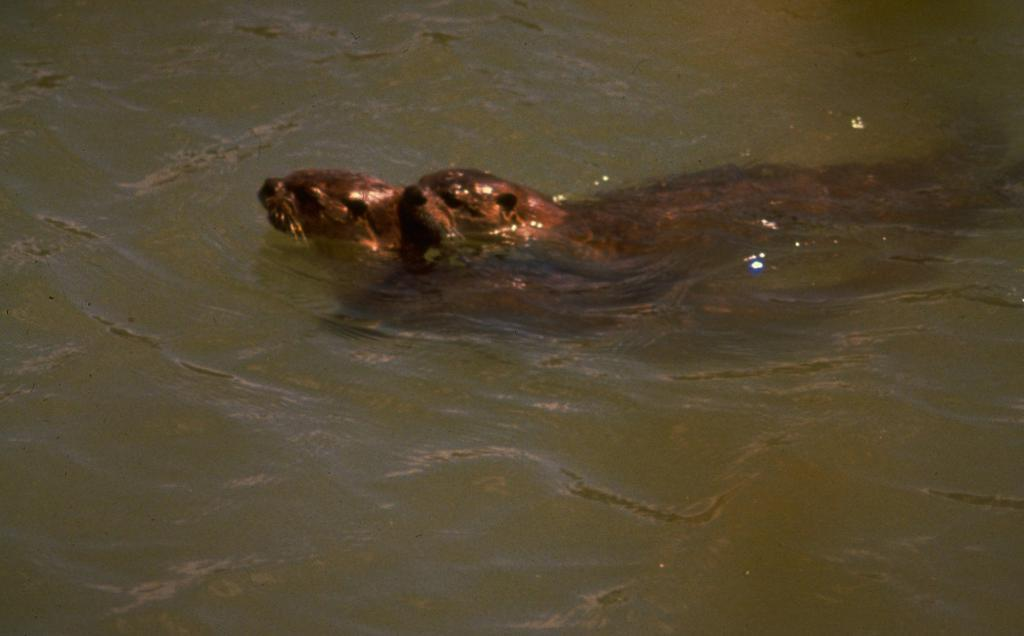What animals are present in the image? There are two seals in the image. Where are the seals located? The seals are in the water. What type of van can be seen distributing fiction books in the image? There is no van present in the image, and the image does not depict any distribution of fiction books. 